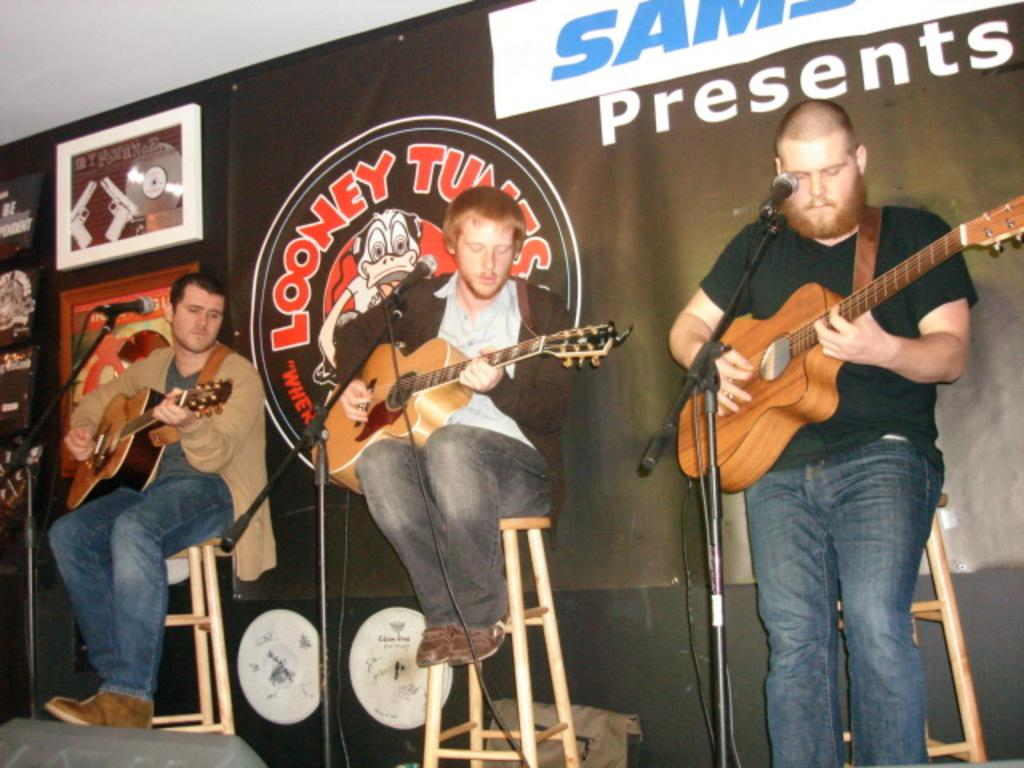What are the three persons in the image doing? The three persons in the image are playing guitar. What objects might be used for amplifying their voices or instruments? There are microphones present in the image. What can be seen in the background of the image? There is a banner visible in the background of the image. What type of structure is present in the image? There is a frame in the image. How many trucks can be seen in the image? There are no trucks present in the image. What type of finger is being used to play the guitar in the image? The image does not show the fingers of the guitar players, so it cannot be determined which type of finger is being used. 